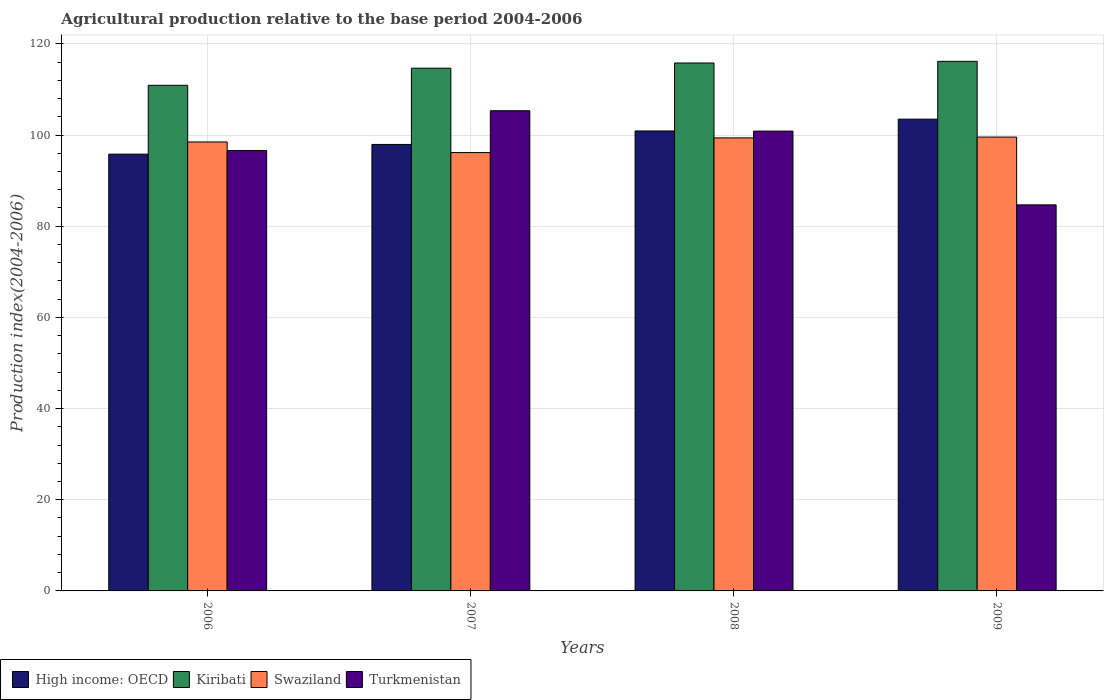Are the number of bars per tick equal to the number of legend labels?
Give a very brief answer. Yes. How many bars are there on the 3rd tick from the left?
Your answer should be very brief. 4. How many bars are there on the 3rd tick from the right?
Offer a very short reply. 4. What is the label of the 4th group of bars from the left?
Give a very brief answer. 2009. What is the agricultural production index in Turkmenistan in 2006?
Your answer should be very brief. 96.59. Across all years, what is the maximum agricultural production index in Kiribati?
Make the answer very short. 116.16. Across all years, what is the minimum agricultural production index in Kiribati?
Your answer should be very brief. 110.91. In which year was the agricultural production index in Kiribati minimum?
Your answer should be compact. 2006. What is the total agricultural production index in Turkmenistan in the graph?
Keep it short and to the point. 387.46. What is the difference between the agricultural production index in Kiribati in 2008 and that in 2009?
Ensure brevity in your answer.  -0.36. What is the difference between the agricultural production index in Kiribati in 2008 and the agricultural production index in Swaziland in 2009?
Ensure brevity in your answer.  16.25. What is the average agricultural production index in High income: OECD per year?
Your answer should be very brief. 99.53. In the year 2009, what is the difference between the agricultural production index in Kiribati and agricultural production index in Swaziland?
Your answer should be very brief. 16.61. In how many years, is the agricultural production index in Kiribati greater than 44?
Your answer should be compact. 4. What is the ratio of the agricultural production index in Turkmenistan in 2007 to that in 2008?
Your answer should be compact. 1.04. Is the agricultural production index in Kiribati in 2008 less than that in 2009?
Provide a succinct answer. Yes. What is the difference between the highest and the second highest agricultural production index in Turkmenistan?
Provide a short and direct response. 4.47. What is the difference between the highest and the lowest agricultural production index in Turkmenistan?
Give a very brief answer. 20.65. What does the 4th bar from the left in 2009 represents?
Keep it short and to the point. Turkmenistan. What does the 4th bar from the right in 2006 represents?
Give a very brief answer. High income: OECD. Is it the case that in every year, the sum of the agricultural production index in Turkmenistan and agricultural production index in High income: OECD is greater than the agricultural production index in Swaziland?
Your answer should be compact. Yes. Are all the bars in the graph horizontal?
Your response must be concise. No. How many years are there in the graph?
Make the answer very short. 4. Are the values on the major ticks of Y-axis written in scientific E-notation?
Your response must be concise. No. Does the graph contain any zero values?
Give a very brief answer. No. Where does the legend appear in the graph?
Your answer should be compact. Bottom left. How are the legend labels stacked?
Ensure brevity in your answer.  Horizontal. What is the title of the graph?
Offer a terse response. Agricultural production relative to the base period 2004-2006. Does "Tunisia" appear as one of the legend labels in the graph?
Offer a very short reply. No. What is the label or title of the X-axis?
Your response must be concise. Years. What is the label or title of the Y-axis?
Your response must be concise. Production index(2004-2006). What is the Production index(2004-2006) in High income: OECD in 2006?
Ensure brevity in your answer.  95.81. What is the Production index(2004-2006) in Kiribati in 2006?
Ensure brevity in your answer.  110.91. What is the Production index(2004-2006) in Swaziland in 2006?
Your answer should be very brief. 98.48. What is the Production index(2004-2006) in Turkmenistan in 2006?
Make the answer very short. 96.59. What is the Production index(2004-2006) of High income: OECD in 2007?
Give a very brief answer. 97.93. What is the Production index(2004-2006) of Kiribati in 2007?
Keep it short and to the point. 114.66. What is the Production index(2004-2006) in Swaziland in 2007?
Keep it short and to the point. 96.15. What is the Production index(2004-2006) in Turkmenistan in 2007?
Keep it short and to the point. 105.33. What is the Production index(2004-2006) in High income: OECD in 2008?
Ensure brevity in your answer.  100.89. What is the Production index(2004-2006) of Kiribati in 2008?
Ensure brevity in your answer.  115.8. What is the Production index(2004-2006) in Swaziland in 2008?
Offer a terse response. 99.37. What is the Production index(2004-2006) of Turkmenistan in 2008?
Offer a terse response. 100.86. What is the Production index(2004-2006) in High income: OECD in 2009?
Keep it short and to the point. 103.48. What is the Production index(2004-2006) in Kiribati in 2009?
Your response must be concise. 116.16. What is the Production index(2004-2006) of Swaziland in 2009?
Keep it short and to the point. 99.55. What is the Production index(2004-2006) of Turkmenistan in 2009?
Your response must be concise. 84.68. Across all years, what is the maximum Production index(2004-2006) of High income: OECD?
Offer a very short reply. 103.48. Across all years, what is the maximum Production index(2004-2006) of Kiribati?
Offer a very short reply. 116.16. Across all years, what is the maximum Production index(2004-2006) of Swaziland?
Make the answer very short. 99.55. Across all years, what is the maximum Production index(2004-2006) of Turkmenistan?
Offer a very short reply. 105.33. Across all years, what is the minimum Production index(2004-2006) of High income: OECD?
Provide a succinct answer. 95.81. Across all years, what is the minimum Production index(2004-2006) of Kiribati?
Offer a terse response. 110.91. Across all years, what is the minimum Production index(2004-2006) in Swaziland?
Offer a very short reply. 96.15. Across all years, what is the minimum Production index(2004-2006) of Turkmenistan?
Your response must be concise. 84.68. What is the total Production index(2004-2006) in High income: OECD in the graph?
Give a very brief answer. 398.11. What is the total Production index(2004-2006) of Kiribati in the graph?
Your answer should be very brief. 457.53. What is the total Production index(2004-2006) of Swaziland in the graph?
Ensure brevity in your answer.  393.55. What is the total Production index(2004-2006) of Turkmenistan in the graph?
Make the answer very short. 387.46. What is the difference between the Production index(2004-2006) of High income: OECD in 2006 and that in 2007?
Ensure brevity in your answer.  -2.13. What is the difference between the Production index(2004-2006) in Kiribati in 2006 and that in 2007?
Your answer should be compact. -3.75. What is the difference between the Production index(2004-2006) in Swaziland in 2006 and that in 2007?
Provide a short and direct response. 2.33. What is the difference between the Production index(2004-2006) in Turkmenistan in 2006 and that in 2007?
Provide a short and direct response. -8.74. What is the difference between the Production index(2004-2006) of High income: OECD in 2006 and that in 2008?
Ensure brevity in your answer.  -5.09. What is the difference between the Production index(2004-2006) in Kiribati in 2006 and that in 2008?
Your answer should be compact. -4.89. What is the difference between the Production index(2004-2006) of Swaziland in 2006 and that in 2008?
Your answer should be very brief. -0.89. What is the difference between the Production index(2004-2006) of Turkmenistan in 2006 and that in 2008?
Your response must be concise. -4.27. What is the difference between the Production index(2004-2006) of High income: OECD in 2006 and that in 2009?
Offer a terse response. -7.67. What is the difference between the Production index(2004-2006) in Kiribati in 2006 and that in 2009?
Provide a short and direct response. -5.25. What is the difference between the Production index(2004-2006) in Swaziland in 2006 and that in 2009?
Keep it short and to the point. -1.07. What is the difference between the Production index(2004-2006) of Turkmenistan in 2006 and that in 2009?
Keep it short and to the point. 11.91. What is the difference between the Production index(2004-2006) of High income: OECD in 2007 and that in 2008?
Ensure brevity in your answer.  -2.96. What is the difference between the Production index(2004-2006) in Kiribati in 2007 and that in 2008?
Your answer should be very brief. -1.14. What is the difference between the Production index(2004-2006) in Swaziland in 2007 and that in 2008?
Give a very brief answer. -3.22. What is the difference between the Production index(2004-2006) in Turkmenistan in 2007 and that in 2008?
Offer a terse response. 4.47. What is the difference between the Production index(2004-2006) of High income: OECD in 2007 and that in 2009?
Your answer should be very brief. -5.54. What is the difference between the Production index(2004-2006) in Swaziland in 2007 and that in 2009?
Ensure brevity in your answer.  -3.4. What is the difference between the Production index(2004-2006) of Turkmenistan in 2007 and that in 2009?
Your response must be concise. 20.65. What is the difference between the Production index(2004-2006) of High income: OECD in 2008 and that in 2009?
Keep it short and to the point. -2.59. What is the difference between the Production index(2004-2006) in Kiribati in 2008 and that in 2009?
Give a very brief answer. -0.36. What is the difference between the Production index(2004-2006) of Swaziland in 2008 and that in 2009?
Make the answer very short. -0.18. What is the difference between the Production index(2004-2006) in Turkmenistan in 2008 and that in 2009?
Your response must be concise. 16.18. What is the difference between the Production index(2004-2006) of High income: OECD in 2006 and the Production index(2004-2006) of Kiribati in 2007?
Your response must be concise. -18.85. What is the difference between the Production index(2004-2006) in High income: OECD in 2006 and the Production index(2004-2006) in Swaziland in 2007?
Your response must be concise. -0.34. What is the difference between the Production index(2004-2006) of High income: OECD in 2006 and the Production index(2004-2006) of Turkmenistan in 2007?
Make the answer very short. -9.52. What is the difference between the Production index(2004-2006) of Kiribati in 2006 and the Production index(2004-2006) of Swaziland in 2007?
Keep it short and to the point. 14.76. What is the difference between the Production index(2004-2006) of Kiribati in 2006 and the Production index(2004-2006) of Turkmenistan in 2007?
Give a very brief answer. 5.58. What is the difference between the Production index(2004-2006) of Swaziland in 2006 and the Production index(2004-2006) of Turkmenistan in 2007?
Offer a terse response. -6.85. What is the difference between the Production index(2004-2006) in High income: OECD in 2006 and the Production index(2004-2006) in Kiribati in 2008?
Your response must be concise. -19.99. What is the difference between the Production index(2004-2006) of High income: OECD in 2006 and the Production index(2004-2006) of Swaziland in 2008?
Give a very brief answer. -3.56. What is the difference between the Production index(2004-2006) of High income: OECD in 2006 and the Production index(2004-2006) of Turkmenistan in 2008?
Provide a succinct answer. -5.05. What is the difference between the Production index(2004-2006) of Kiribati in 2006 and the Production index(2004-2006) of Swaziland in 2008?
Your response must be concise. 11.54. What is the difference between the Production index(2004-2006) in Kiribati in 2006 and the Production index(2004-2006) in Turkmenistan in 2008?
Offer a terse response. 10.05. What is the difference between the Production index(2004-2006) in Swaziland in 2006 and the Production index(2004-2006) in Turkmenistan in 2008?
Provide a short and direct response. -2.38. What is the difference between the Production index(2004-2006) in High income: OECD in 2006 and the Production index(2004-2006) in Kiribati in 2009?
Offer a terse response. -20.35. What is the difference between the Production index(2004-2006) of High income: OECD in 2006 and the Production index(2004-2006) of Swaziland in 2009?
Your answer should be compact. -3.74. What is the difference between the Production index(2004-2006) of High income: OECD in 2006 and the Production index(2004-2006) of Turkmenistan in 2009?
Offer a very short reply. 11.13. What is the difference between the Production index(2004-2006) in Kiribati in 2006 and the Production index(2004-2006) in Swaziland in 2009?
Keep it short and to the point. 11.36. What is the difference between the Production index(2004-2006) in Kiribati in 2006 and the Production index(2004-2006) in Turkmenistan in 2009?
Your answer should be very brief. 26.23. What is the difference between the Production index(2004-2006) of High income: OECD in 2007 and the Production index(2004-2006) of Kiribati in 2008?
Keep it short and to the point. -17.87. What is the difference between the Production index(2004-2006) in High income: OECD in 2007 and the Production index(2004-2006) in Swaziland in 2008?
Keep it short and to the point. -1.44. What is the difference between the Production index(2004-2006) of High income: OECD in 2007 and the Production index(2004-2006) of Turkmenistan in 2008?
Your answer should be very brief. -2.93. What is the difference between the Production index(2004-2006) of Kiribati in 2007 and the Production index(2004-2006) of Swaziland in 2008?
Keep it short and to the point. 15.29. What is the difference between the Production index(2004-2006) in Kiribati in 2007 and the Production index(2004-2006) in Turkmenistan in 2008?
Ensure brevity in your answer.  13.8. What is the difference between the Production index(2004-2006) of Swaziland in 2007 and the Production index(2004-2006) of Turkmenistan in 2008?
Offer a terse response. -4.71. What is the difference between the Production index(2004-2006) in High income: OECD in 2007 and the Production index(2004-2006) in Kiribati in 2009?
Your answer should be compact. -18.23. What is the difference between the Production index(2004-2006) in High income: OECD in 2007 and the Production index(2004-2006) in Swaziland in 2009?
Keep it short and to the point. -1.62. What is the difference between the Production index(2004-2006) in High income: OECD in 2007 and the Production index(2004-2006) in Turkmenistan in 2009?
Provide a short and direct response. 13.25. What is the difference between the Production index(2004-2006) in Kiribati in 2007 and the Production index(2004-2006) in Swaziland in 2009?
Make the answer very short. 15.11. What is the difference between the Production index(2004-2006) in Kiribati in 2007 and the Production index(2004-2006) in Turkmenistan in 2009?
Your answer should be compact. 29.98. What is the difference between the Production index(2004-2006) in Swaziland in 2007 and the Production index(2004-2006) in Turkmenistan in 2009?
Your response must be concise. 11.47. What is the difference between the Production index(2004-2006) in High income: OECD in 2008 and the Production index(2004-2006) in Kiribati in 2009?
Provide a short and direct response. -15.27. What is the difference between the Production index(2004-2006) of High income: OECD in 2008 and the Production index(2004-2006) of Swaziland in 2009?
Provide a succinct answer. 1.34. What is the difference between the Production index(2004-2006) in High income: OECD in 2008 and the Production index(2004-2006) in Turkmenistan in 2009?
Keep it short and to the point. 16.21. What is the difference between the Production index(2004-2006) in Kiribati in 2008 and the Production index(2004-2006) in Swaziland in 2009?
Offer a very short reply. 16.25. What is the difference between the Production index(2004-2006) of Kiribati in 2008 and the Production index(2004-2006) of Turkmenistan in 2009?
Provide a short and direct response. 31.12. What is the difference between the Production index(2004-2006) of Swaziland in 2008 and the Production index(2004-2006) of Turkmenistan in 2009?
Offer a terse response. 14.69. What is the average Production index(2004-2006) of High income: OECD per year?
Make the answer very short. 99.53. What is the average Production index(2004-2006) of Kiribati per year?
Offer a terse response. 114.38. What is the average Production index(2004-2006) of Swaziland per year?
Offer a very short reply. 98.39. What is the average Production index(2004-2006) of Turkmenistan per year?
Offer a very short reply. 96.86. In the year 2006, what is the difference between the Production index(2004-2006) in High income: OECD and Production index(2004-2006) in Kiribati?
Your response must be concise. -15.1. In the year 2006, what is the difference between the Production index(2004-2006) in High income: OECD and Production index(2004-2006) in Swaziland?
Keep it short and to the point. -2.67. In the year 2006, what is the difference between the Production index(2004-2006) of High income: OECD and Production index(2004-2006) of Turkmenistan?
Offer a very short reply. -0.78. In the year 2006, what is the difference between the Production index(2004-2006) of Kiribati and Production index(2004-2006) of Swaziland?
Keep it short and to the point. 12.43. In the year 2006, what is the difference between the Production index(2004-2006) of Kiribati and Production index(2004-2006) of Turkmenistan?
Your answer should be compact. 14.32. In the year 2006, what is the difference between the Production index(2004-2006) of Swaziland and Production index(2004-2006) of Turkmenistan?
Make the answer very short. 1.89. In the year 2007, what is the difference between the Production index(2004-2006) of High income: OECD and Production index(2004-2006) of Kiribati?
Give a very brief answer. -16.73. In the year 2007, what is the difference between the Production index(2004-2006) in High income: OECD and Production index(2004-2006) in Swaziland?
Keep it short and to the point. 1.78. In the year 2007, what is the difference between the Production index(2004-2006) in High income: OECD and Production index(2004-2006) in Turkmenistan?
Offer a terse response. -7.4. In the year 2007, what is the difference between the Production index(2004-2006) of Kiribati and Production index(2004-2006) of Swaziland?
Keep it short and to the point. 18.51. In the year 2007, what is the difference between the Production index(2004-2006) in Kiribati and Production index(2004-2006) in Turkmenistan?
Give a very brief answer. 9.33. In the year 2007, what is the difference between the Production index(2004-2006) of Swaziland and Production index(2004-2006) of Turkmenistan?
Keep it short and to the point. -9.18. In the year 2008, what is the difference between the Production index(2004-2006) in High income: OECD and Production index(2004-2006) in Kiribati?
Your answer should be compact. -14.91. In the year 2008, what is the difference between the Production index(2004-2006) of High income: OECD and Production index(2004-2006) of Swaziland?
Give a very brief answer. 1.52. In the year 2008, what is the difference between the Production index(2004-2006) in High income: OECD and Production index(2004-2006) in Turkmenistan?
Ensure brevity in your answer.  0.03. In the year 2008, what is the difference between the Production index(2004-2006) in Kiribati and Production index(2004-2006) in Swaziland?
Make the answer very short. 16.43. In the year 2008, what is the difference between the Production index(2004-2006) of Kiribati and Production index(2004-2006) of Turkmenistan?
Ensure brevity in your answer.  14.94. In the year 2008, what is the difference between the Production index(2004-2006) in Swaziland and Production index(2004-2006) in Turkmenistan?
Ensure brevity in your answer.  -1.49. In the year 2009, what is the difference between the Production index(2004-2006) in High income: OECD and Production index(2004-2006) in Kiribati?
Ensure brevity in your answer.  -12.68. In the year 2009, what is the difference between the Production index(2004-2006) of High income: OECD and Production index(2004-2006) of Swaziland?
Keep it short and to the point. 3.93. In the year 2009, what is the difference between the Production index(2004-2006) in High income: OECD and Production index(2004-2006) in Turkmenistan?
Give a very brief answer. 18.8. In the year 2009, what is the difference between the Production index(2004-2006) of Kiribati and Production index(2004-2006) of Swaziland?
Keep it short and to the point. 16.61. In the year 2009, what is the difference between the Production index(2004-2006) of Kiribati and Production index(2004-2006) of Turkmenistan?
Keep it short and to the point. 31.48. In the year 2009, what is the difference between the Production index(2004-2006) of Swaziland and Production index(2004-2006) of Turkmenistan?
Your response must be concise. 14.87. What is the ratio of the Production index(2004-2006) of High income: OECD in 2006 to that in 2007?
Your answer should be compact. 0.98. What is the ratio of the Production index(2004-2006) of Kiribati in 2006 to that in 2007?
Give a very brief answer. 0.97. What is the ratio of the Production index(2004-2006) of Swaziland in 2006 to that in 2007?
Your answer should be very brief. 1.02. What is the ratio of the Production index(2004-2006) in Turkmenistan in 2006 to that in 2007?
Provide a succinct answer. 0.92. What is the ratio of the Production index(2004-2006) of High income: OECD in 2006 to that in 2008?
Offer a terse response. 0.95. What is the ratio of the Production index(2004-2006) of Kiribati in 2006 to that in 2008?
Your response must be concise. 0.96. What is the ratio of the Production index(2004-2006) in Swaziland in 2006 to that in 2008?
Keep it short and to the point. 0.99. What is the ratio of the Production index(2004-2006) of Turkmenistan in 2006 to that in 2008?
Make the answer very short. 0.96. What is the ratio of the Production index(2004-2006) of High income: OECD in 2006 to that in 2009?
Provide a short and direct response. 0.93. What is the ratio of the Production index(2004-2006) of Kiribati in 2006 to that in 2009?
Your response must be concise. 0.95. What is the ratio of the Production index(2004-2006) in Swaziland in 2006 to that in 2009?
Provide a succinct answer. 0.99. What is the ratio of the Production index(2004-2006) in Turkmenistan in 2006 to that in 2009?
Your answer should be compact. 1.14. What is the ratio of the Production index(2004-2006) in High income: OECD in 2007 to that in 2008?
Offer a very short reply. 0.97. What is the ratio of the Production index(2004-2006) in Kiribati in 2007 to that in 2008?
Keep it short and to the point. 0.99. What is the ratio of the Production index(2004-2006) in Swaziland in 2007 to that in 2008?
Provide a succinct answer. 0.97. What is the ratio of the Production index(2004-2006) in Turkmenistan in 2007 to that in 2008?
Your answer should be very brief. 1.04. What is the ratio of the Production index(2004-2006) in High income: OECD in 2007 to that in 2009?
Your response must be concise. 0.95. What is the ratio of the Production index(2004-2006) of Kiribati in 2007 to that in 2009?
Your answer should be compact. 0.99. What is the ratio of the Production index(2004-2006) of Swaziland in 2007 to that in 2009?
Provide a succinct answer. 0.97. What is the ratio of the Production index(2004-2006) of Turkmenistan in 2007 to that in 2009?
Provide a short and direct response. 1.24. What is the ratio of the Production index(2004-2006) in High income: OECD in 2008 to that in 2009?
Ensure brevity in your answer.  0.97. What is the ratio of the Production index(2004-2006) of Kiribati in 2008 to that in 2009?
Provide a succinct answer. 1. What is the ratio of the Production index(2004-2006) in Turkmenistan in 2008 to that in 2009?
Provide a succinct answer. 1.19. What is the difference between the highest and the second highest Production index(2004-2006) of High income: OECD?
Make the answer very short. 2.59. What is the difference between the highest and the second highest Production index(2004-2006) in Kiribati?
Give a very brief answer. 0.36. What is the difference between the highest and the second highest Production index(2004-2006) of Swaziland?
Provide a succinct answer. 0.18. What is the difference between the highest and the second highest Production index(2004-2006) of Turkmenistan?
Your response must be concise. 4.47. What is the difference between the highest and the lowest Production index(2004-2006) in High income: OECD?
Make the answer very short. 7.67. What is the difference between the highest and the lowest Production index(2004-2006) of Kiribati?
Offer a terse response. 5.25. What is the difference between the highest and the lowest Production index(2004-2006) in Swaziland?
Make the answer very short. 3.4. What is the difference between the highest and the lowest Production index(2004-2006) of Turkmenistan?
Your response must be concise. 20.65. 